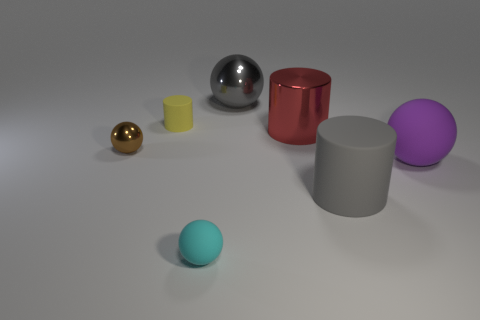How many other things are the same color as the big metal ball?
Give a very brief answer. 1. Is there any other thing that has the same size as the cyan matte ball?
Offer a very short reply. Yes. How many other things are the same shape as the purple thing?
Offer a terse response. 3. Do the purple rubber object and the yellow rubber cylinder have the same size?
Ensure brevity in your answer.  No. Are there any large purple spheres?
Give a very brief answer. Yes. Is there anything else that is the same material as the gray sphere?
Provide a short and direct response. Yes. Are there any small green cylinders made of the same material as the large purple thing?
Offer a terse response. No. There is a purple ball that is the same size as the shiny cylinder; what material is it?
Offer a terse response. Rubber. What number of other tiny rubber objects have the same shape as the cyan thing?
Your answer should be very brief. 0. There is a red cylinder that is made of the same material as the tiny brown thing; what is its size?
Ensure brevity in your answer.  Large. 